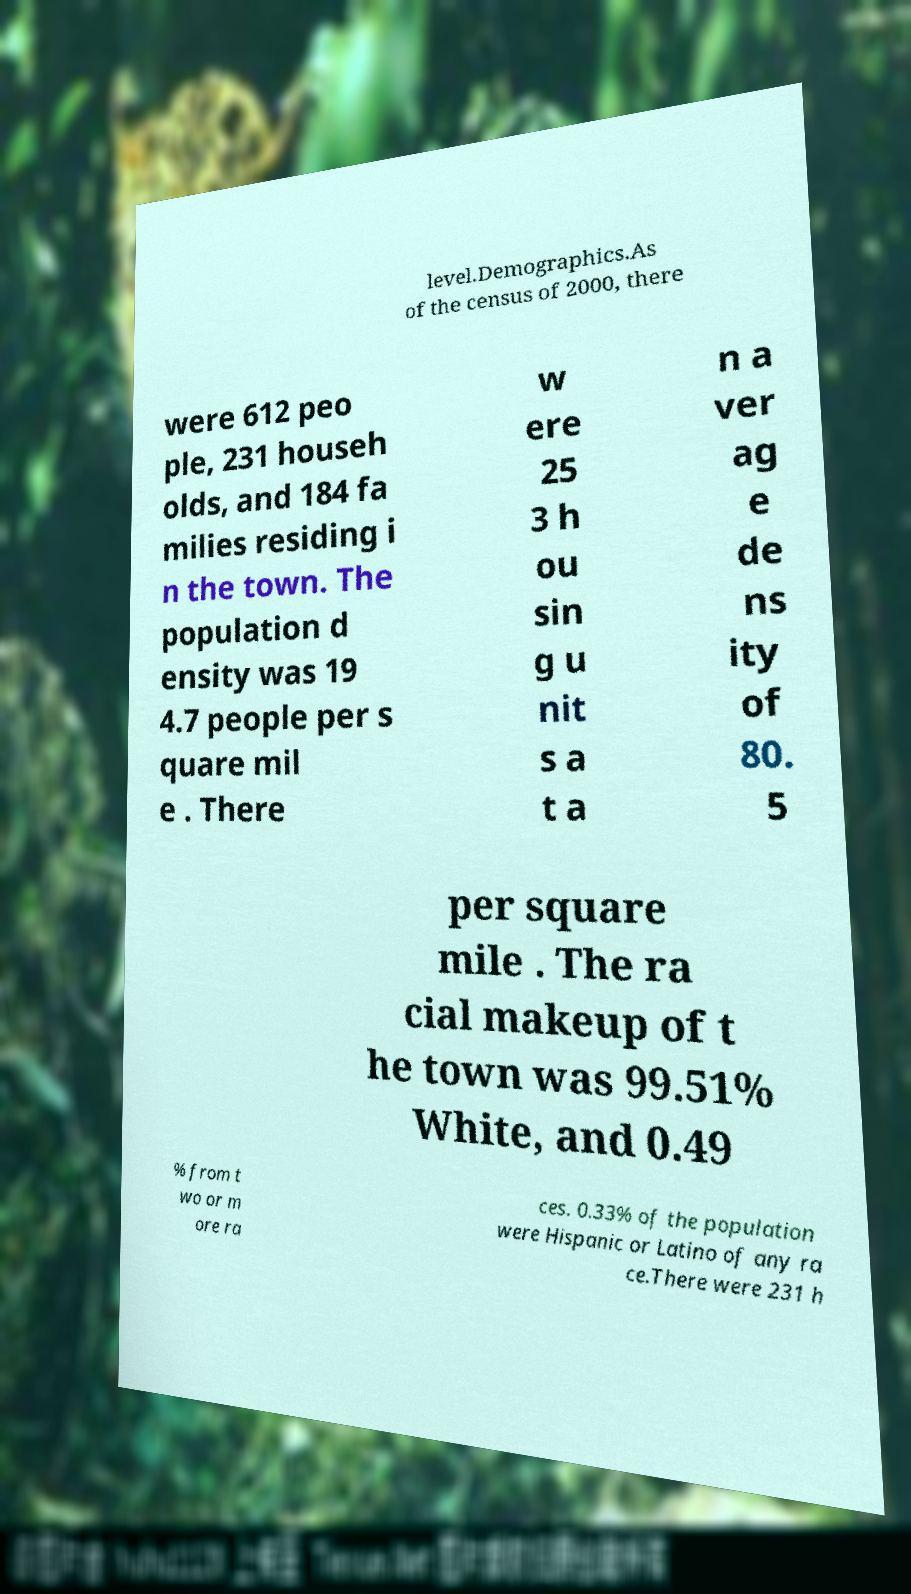Can you read and provide the text displayed in the image?This photo seems to have some interesting text. Can you extract and type it out for me? level.Demographics.As of the census of 2000, there were 612 peo ple, 231 househ olds, and 184 fa milies residing i n the town. The population d ensity was 19 4.7 people per s quare mil e . There w ere 25 3 h ou sin g u nit s a t a n a ver ag e de ns ity of 80. 5 per square mile . The ra cial makeup of t he town was 99.51% White, and 0.49 % from t wo or m ore ra ces. 0.33% of the population were Hispanic or Latino of any ra ce.There were 231 h 